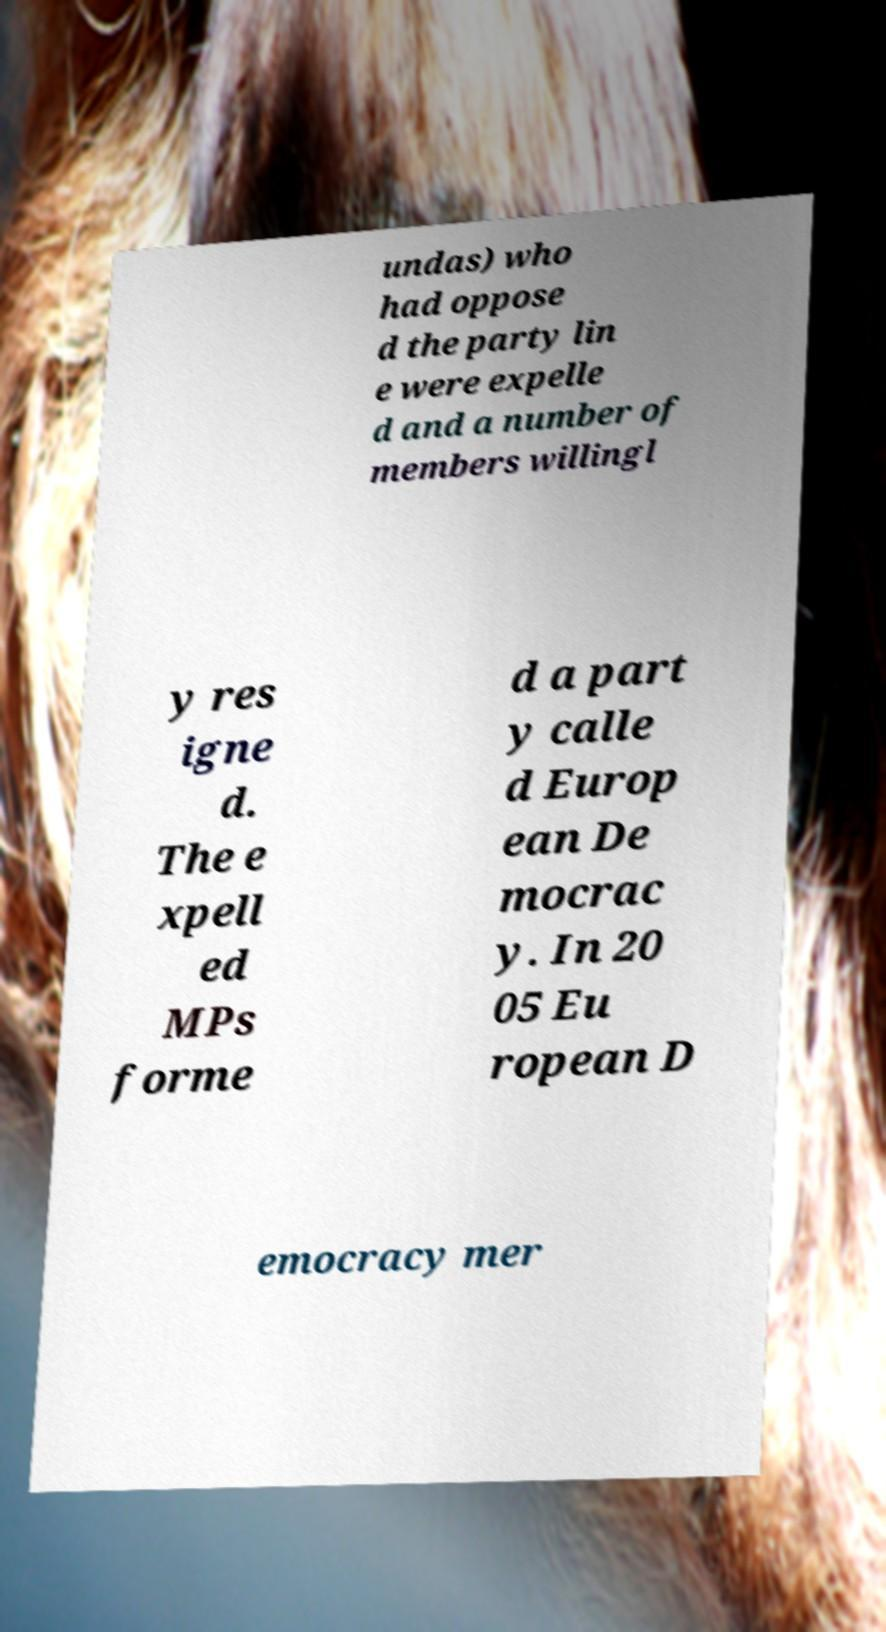Could you assist in decoding the text presented in this image and type it out clearly? undas) who had oppose d the party lin e were expelle d and a number of members willingl y res igne d. The e xpell ed MPs forme d a part y calle d Europ ean De mocrac y. In 20 05 Eu ropean D emocracy mer 